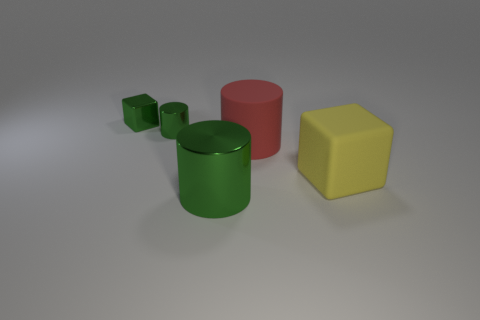Add 4 red balls. How many objects exist? 9 Subtract all blocks. How many objects are left? 3 Add 3 large matte things. How many large matte things exist? 5 Subtract 2 green cylinders. How many objects are left? 3 Subtract all big rubber cylinders. Subtract all metallic things. How many objects are left? 1 Add 3 tiny green metallic objects. How many tiny green metallic objects are left? 5 